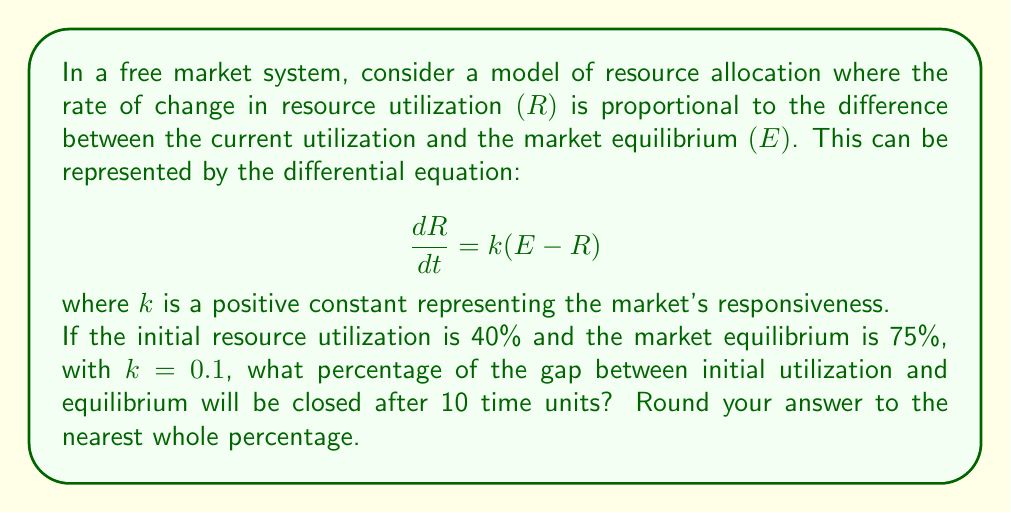Can you answer this question? To solve this problem, we need to follow these steps:

1) First, let's solve the differential equation. This is a first-order linear differential equation.

   $$\frac{dR}{dt} = k(E - R)$$

2) The solution to this equation is:

   $$R(t) = E + (R_0 - E)e^{-kt}$$

   where $R_0$ is the initial resource utilization.

3) We're given:
   $R_0 = 40\%$
   $E = 75\%$
   $k = 0.1$
   $t = 10$

4) Let's substitute these values into our solution:

   $$R(10) = 75\% + (40\% - 75\%)e^{-0.1 \cdot 10}$$

5) Simplify:
   $$R(10) = 75\% - 35\%e^{-1}$$

6) Calculate:
   $$R(10) \approx 75\% - 35\% \cdot 0.3679 \approx 62.13\%$$

7) To find the percentage of the gap closed, we calculate:

   $$\text{Percentage closed} = \frac{\text{Change in R}}{\text{Total gap}} \cdot 100\%$$

   $$= \frac{62.13\% - 40\%}{75\% - 40\%} \cdot 100\% \approx 63.23\%$$

8) Rounding to the nearest whole percentage gives us 63%.
Answer: 63% 